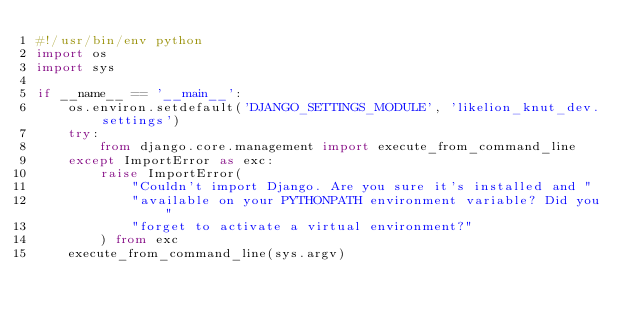Convert code to text. <code><loc_0><loc_0><loc_500><loc_500><_Python_>#!/usr/bin/env python
import os
import sys

if __name__ == '__main__':
    os.environ.setdefault('DJANGO_SETTINGS_MODULE', 'likelion_knut_dev.settings')
    try:
        from django.core.management import execute_from_command_line
    except ImportError as exc:
        raise ImportError(
            "Couldn't import Django. Are you sure it's installed and "
            "available on your PYTHONPATH environment variable? Did you "
            "forget to activate a virtual environment?"
        ) from exc
    execute_from_command_line(sys.argv)
</code> 